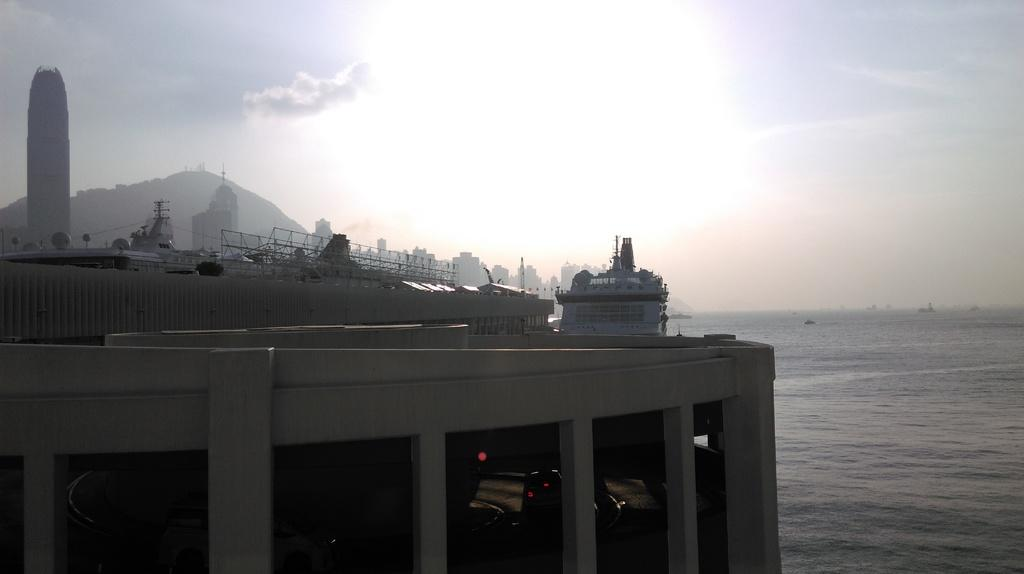What type of structures can be seen in the image? There are buildings in the image. What type of vehicles are present in the image? There are boats and ships in the image. What is the primary body of water in the image? There is water visible in the image. What type of geographical feature is present in the image? There is a hill in the image. What is the weather like in the image? The sky is cloudy in the image. Can you tell me which actor is performing on the hill in the image? There is no actor performing on the hill in the image; it is a geographical feature. What type of stick is being used by the boats in the image? There are no sticks present in the image; the boats are navigating through the water. 